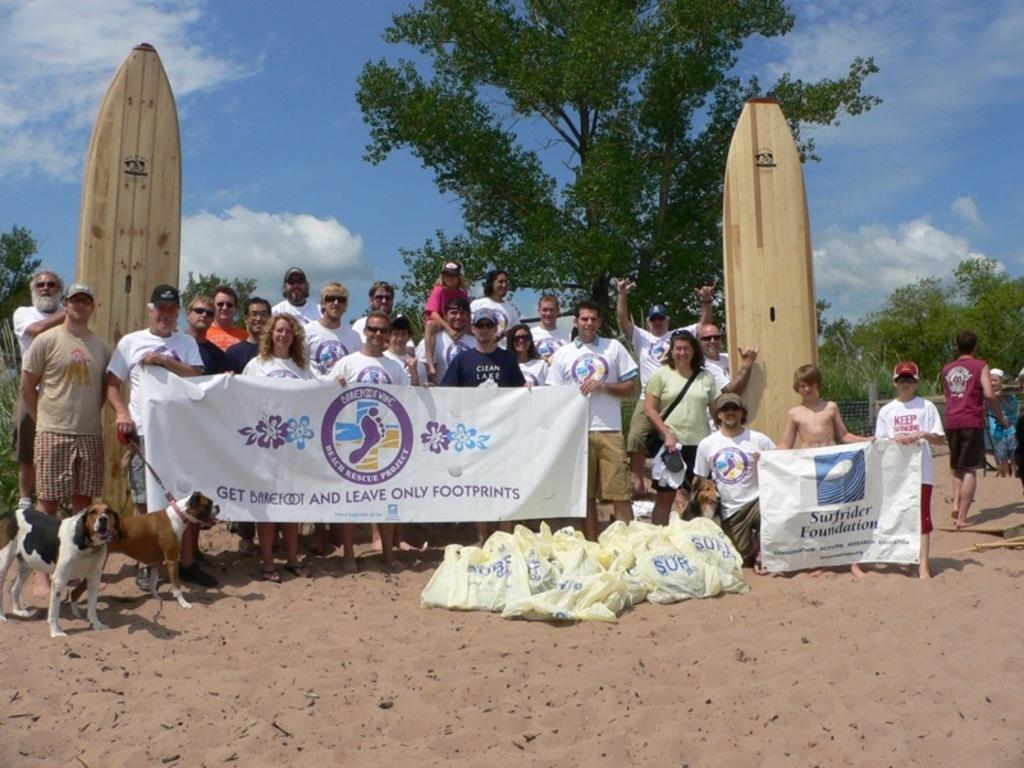Can you describe this image briefly? This is a picture out side of a city and there are some persons standing and holding a hoarding board and on the hoarding board there i s a some text written and back side of them there are some trees , sky visible in the background and left side there are the two dogs stand on the floor. 